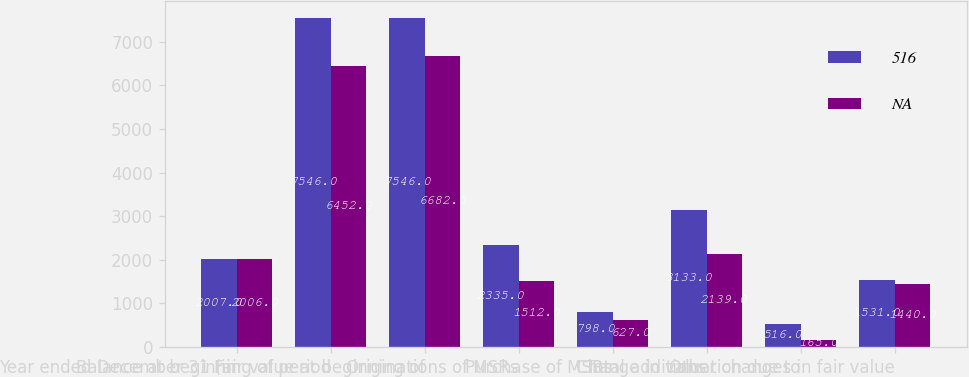<chart> <loc_0><loc_0><loc_500><loc_500><stacked_bar_chart><ecel><fcel>Year ended December 31 (in<fcel>Balance at beginning of period<fcel>Fair value at beginning of<fcel>Originations of MSRs<fcel>Purchase of MSRs<fcel>Total additions<fcel>Change in valuation due to<fcel>Other changes in fair value<nl><fcel>516<fcel>2007<fcel>7546<fcel>7546<fcel>2335<fcel>798<fcel>3133<fcel>516<fcel>1531<nl><fcel>nan<fcel>2006<fcel>6452<fcel>6682<fcel>1512<fcel>627<fcel>2139<fcel>165<fcel>1440<nl></chart> 